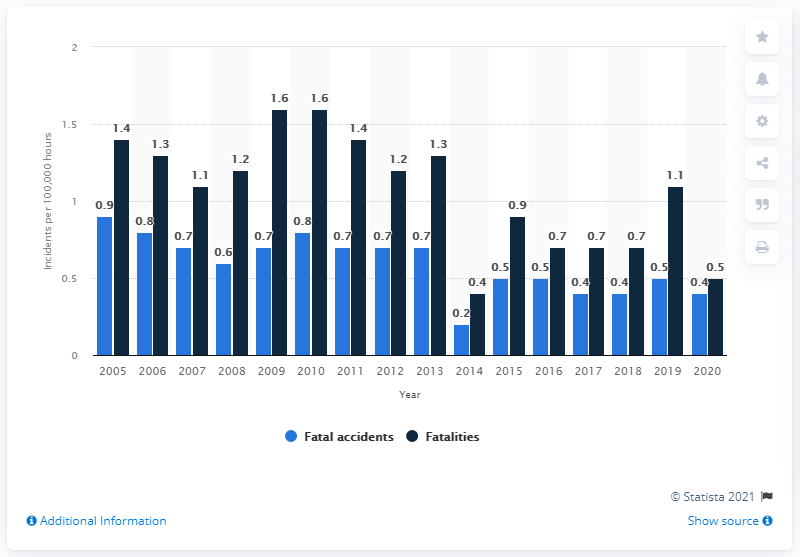Mention a couple of crucial points in this snapshot. There were zero fatal accidents per 100,000 flight hours that occurred involving Canadian aircraft in 2020. 